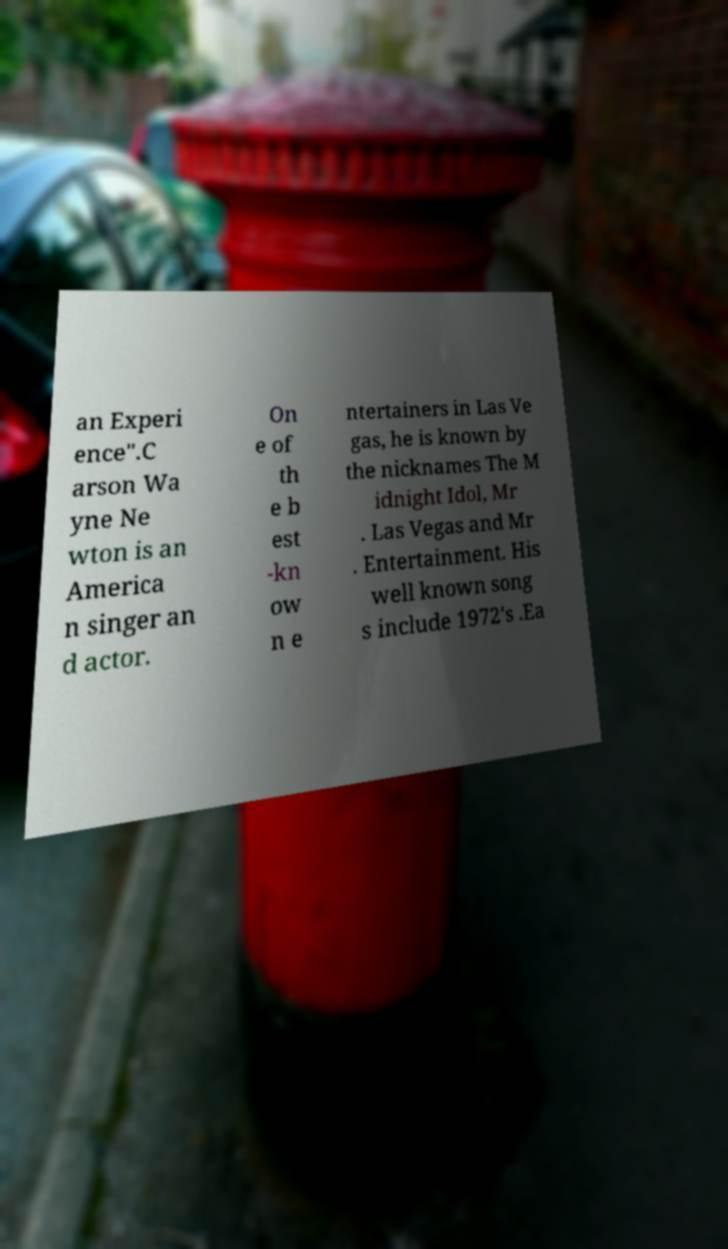Please identify and transcribe the text found in this image. an Experi ence".C arson Wa yne Ne wton is an America n singer an d actor. On e of th e b est -kn ow n e ntertainers in Las Ve gas, he is known by the nicknames The M idnight Idol, Mr . Las Vegas and Mr . Entertainment. His well known song s include 1972's .Ea 